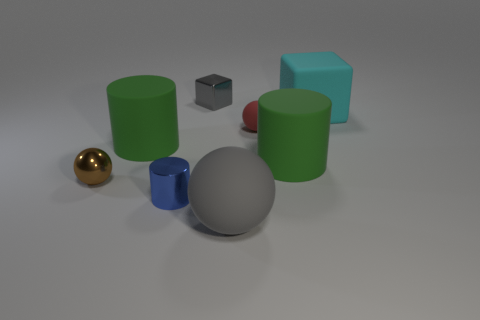There is a rubber block; what number of balls are in front of it?
Offer a terse response. 3. What number of things are small yellow shiny cubes or matte cylinders?
Ensure brevity in your answer.  2. How many matte cylinders have the same size as the red thing?
Ensure brevity in your answer.  0. What is the shape of the big green object behind the large rubber cylinder that is to the right of the blue metal object?
Your response must be concise. Cylinder. Are there fewer small gray shiny objects than brown rubber balls?
Your response must be concise. No. The thing behind the cyan rubber cube is what color?
Offer a terse response. Gray. There is a large thing that is in front of the red matte thing and on the right side of the small red rubber ball; what material is it made of?
Offer a terse response. Rubber. There is a small object that is made of the same material as the big gray ball; what shape is it?
Your answer should be compact. Sphere. How many tiny things are in front of the big green rubber cylinder on the left side of the tiny blue metal object?
Ensure brevity in your answer.  2. What number of small metallic objects are both behind the tiny blue cylinder and left of the small gray object?
Your response must be concise. 1. 